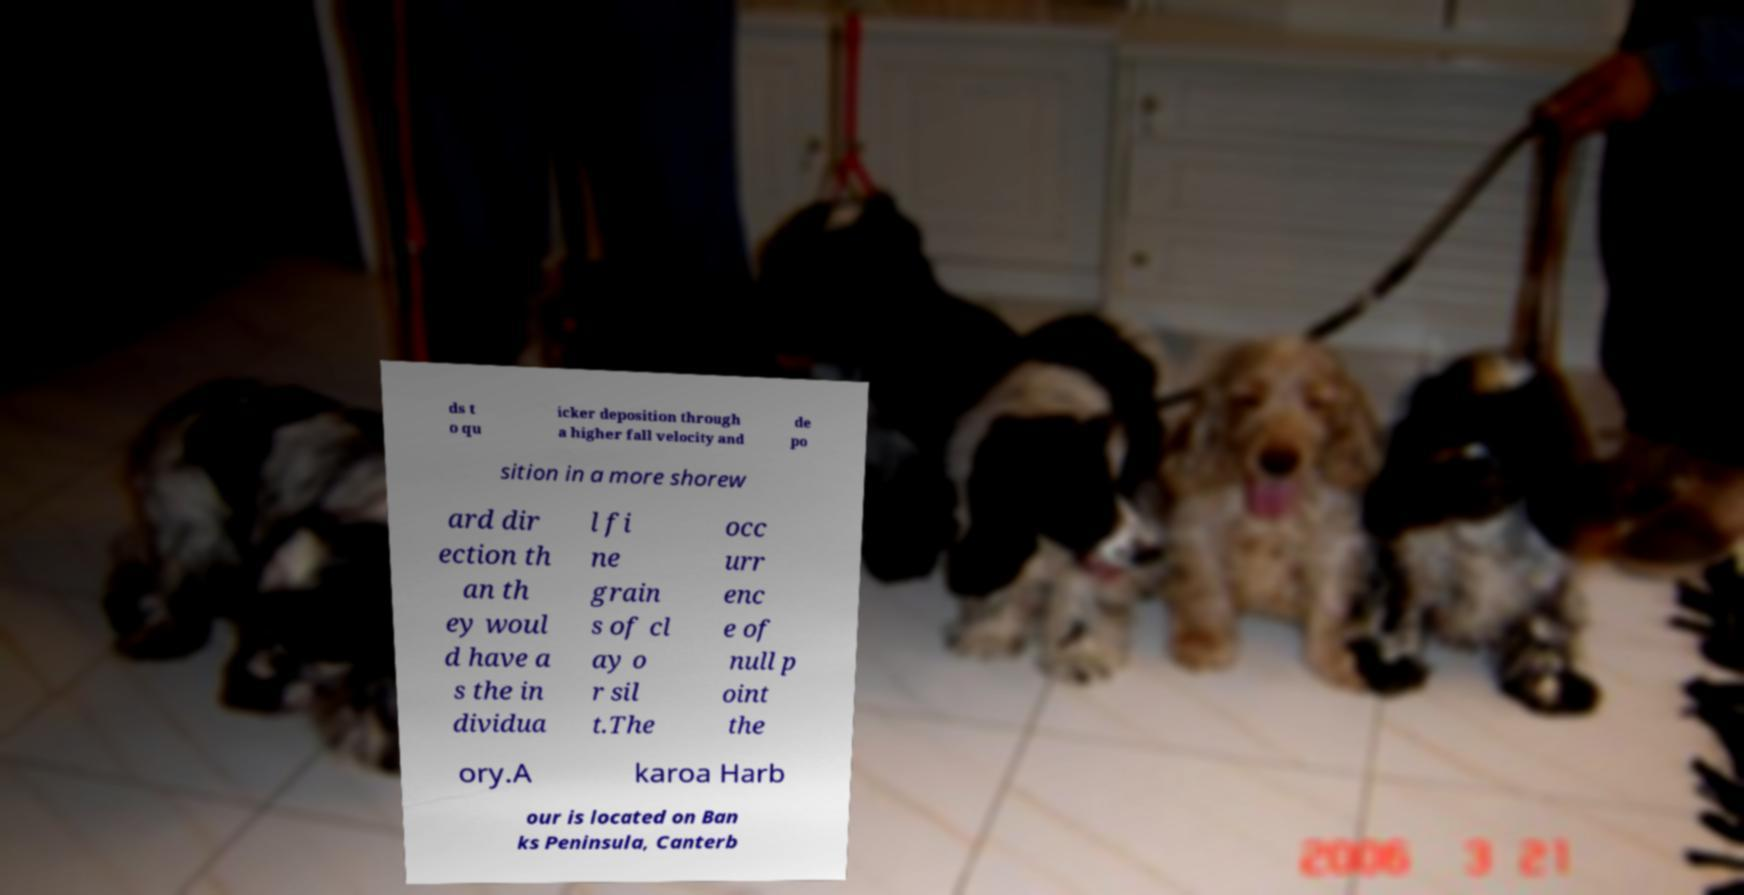I need the written content from this picture converted into text. Can you do that? ds t o qu icker deposition through a higher fall velocity and de po sition in a more shorew ard dir ection th an th ey woul d have a s the in dividua l fi ne grain s of cl ay o r sil t.The occ urr enc e of null p oint the ory.A karoa Harb our is located on Ban ks Peninsula, Canterb 